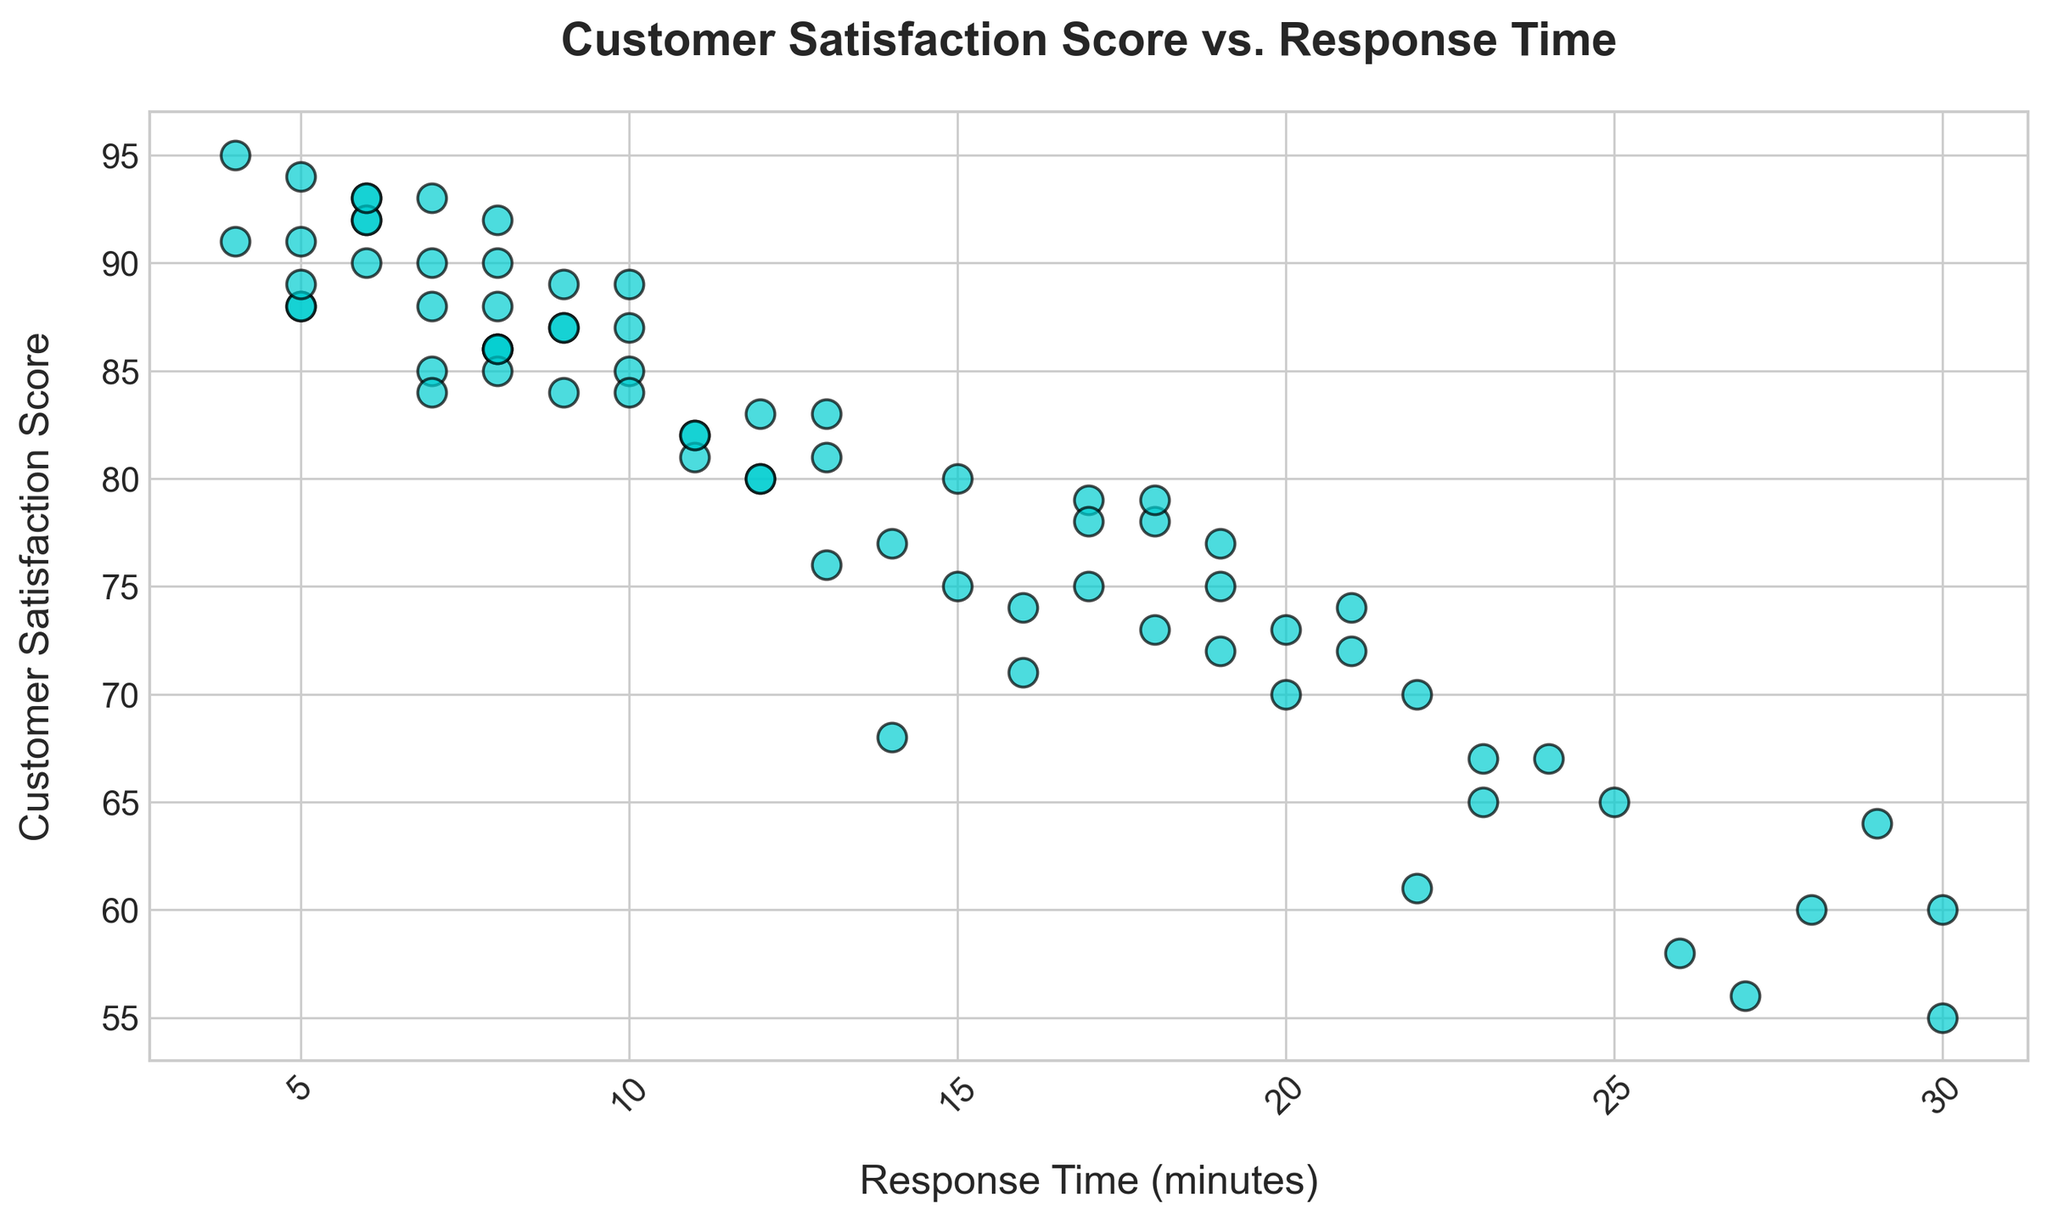What's the general trend between Customer Satisfaction Score and Response Time? By examining the scatter plot visually, we can observe that as the Response Time increases, the Customer Satisfaction Score tends to decrease. This indicates a negative trend or relationship between these two variables.
Answer: Negative trend Is there any outlier in the Customer Satisfaction Score for response times greater than 25 minutes? Looking at the data points beyond 25 minutes of response time, we can see that one data point has a Customer Satisfaction Score of 55, which seems significantly lower than the other scores in this range.
Answer: Yes, score of 55 Which point on the graph has the highest Customer Satisfaction Score, and what is its Response Time? By identifying the highest point on the y-axis, we can see that the highest Customer Satisfaction Score is 95, corresponding to a Response Time of 4 minutes.
Answer: 95 score at 4 minutes What is the difference in Customer Satisfaction Score between the quickest response time and the slowest response time? The quickest response time is 4 minutes with a score of 95, and the slowest response time is 30 minutes with a score of 55. The difference is calculated as 95 - 55.
Answer: 40 For response times between 10 and 20 minutes, what is the average Customer Satisfaction Score? First, identify the points between 10 and 20 minutes: 85, 78, 82, 93, 84, 86, 73, 88, 92, 84, 77. Add these scores and divide by the number of data points: (85 + 78 + 82 + 93 + 84 + 86 + 73 + 88 + 92 + 84 + 77) / 11.
Answer: 83.45 Are there more data points with Customer Satisfaction Scores above 85 or below 85? Count the number of data points above 85 and below 85 visually. There are more data points above the score of 85 compared to those below it.
Answer: More above 85 What's the median Customer Satisfaction Score for response times under 15 minutes? Identify the scores for response times under 15 minutes: 88, 75, 90, 85, 92, 89, 95, 87, 91, 86, 84, 80, 90, 88, 86, 89, 90, 88, 87, 92, 90. As there are 21 data points, the median is the 11th score when sorted: 85, 86, 86, 87, 87, 88, 88, 88, 89, 89, 90, 90, 90, 90, 91, 92, 92, 92, 95. The median value is 89.
Answer: 89 Which data point has both a Customer Satisfaction Score and Response Time closest to the average values on both axes? First calculate the average for Response Time and Customer Satisfaction Score. Response Time average: 16.6, Satisfaction Score average: 84.4. The data point (12, 84) is closest to these averages.
Answer: (12, 84) Is there any instance where a longer response time results in a higher Customer Satisfaction Score compared to a shorter response time? Yes, by comparing pairs, we see that for a response time of 12 minutes with a score of 80, a shorter response time of 11 minutes has a higher score of 82. However, other response times like 5 minutes, with a score of 88, are less than some longer response times like 12 minutes with a score of 84, contradicting the general trend. This shows inconsistencies where longer response times sometimes result in higher scores.
Answer: Yes 